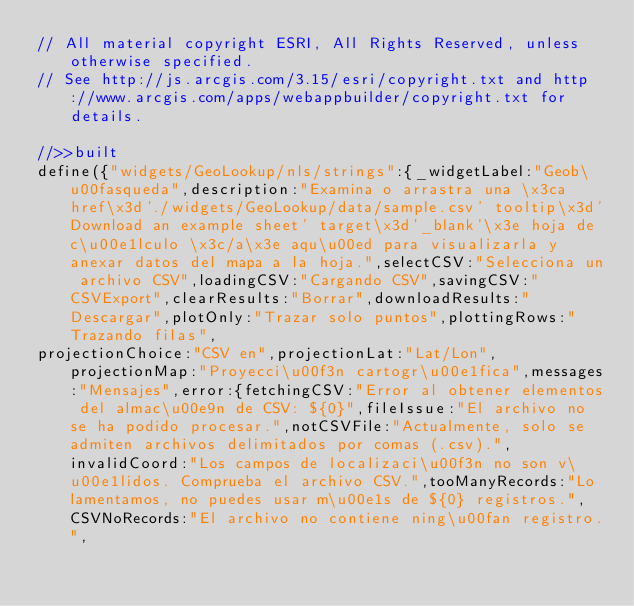Convert code to text. <code><loc_0><loc_0><loc_500><loc_500><_JavaScript_>// All material copyright ESRI, All Rights Reserved, unless otherwise specified.
// See http://js.arcgis.com/3.15/esri/copyright.txt and http://www.arcgis.com/apps/webappbuilder/copyright.txt for details.
//>>built
define({"widgets/GeoLookup/nls/strings":{_widgetLabel:"Geob\u00fasqueda",description:"Examina o arrastra una \x3ca href\x3d'./widgets/GeoLookup/data/sample.csv' tooltip\x3d'Download an example sheet' target\x3d'_blank'\x3e hoja de c\u00e1lculo \x3c/a\x3e aqu\u00ed para visualizarla y anexar datos del mapa a la hoja.",selectCSV:"Selecciona un archivo CSV",loadingCSV:"Cargando CSV",savingCSV:"CSVExport",clearResults:"Borrar",downloadResults:"Descargar",plotOnly:"Trazar solo puntos",plottingRows:"Trazando filas",
projectionChoice:"CSV en",projectionLat:"Lat/Lon",projectionMap:"Proyecci\u00f3n cartogr\u00e1fica",messages:"Mensajes",error:{fetchingCSV:"Error al obtener elementos del almac\u00e9n de CSV: ${0}",fileIssue:"El archivo no se ha podido procesar.",notCSVFile:"Actualmente, solo se admiten archivos delimitados por comas (.csv).",invalidCoord:"Los campos de localizaci\u00f3n no son v\u00e1lidos. Comprueba el archivo CSV.",tooManyRecords:"Lo lamentamos, no puedes usar m\u00e1s de ${0} registros.",CSVNoRecords:"El archivo no contiene ning\u00fan registro.",</code> 